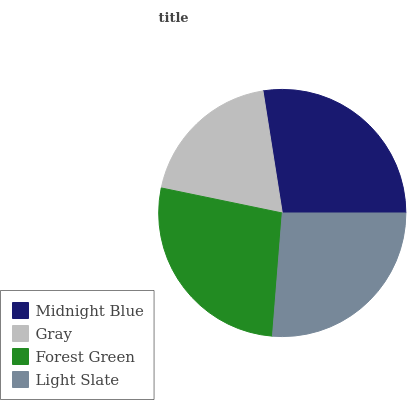Is Gray the minimum?
Answer yes or no. Yes. Is Midnight Blue the maximum?
Answer yes or no. Yes. Is Forest Green the minimum?
Answer yes or no. No. Is Forest Green the maximum?
Answer yes or no. No. Is Forest Green greater than Gray?
Answer yes or no. Yes. Is Gray less than Forest Green?
Answer yes or no. Yes. Is Gray greater than Forest Green?
Answer yes or no. No. Is Forest Green less than Gray?
Answer yes or no. No. Is Forest Green the high median?
Answer yes or no. Yes. Is Light Slate the low median?
Answer yes or no. Yes. Is Gray the high median?
Answer yes or no. No. Is Gray the low median?
Answer yes or no. No. 